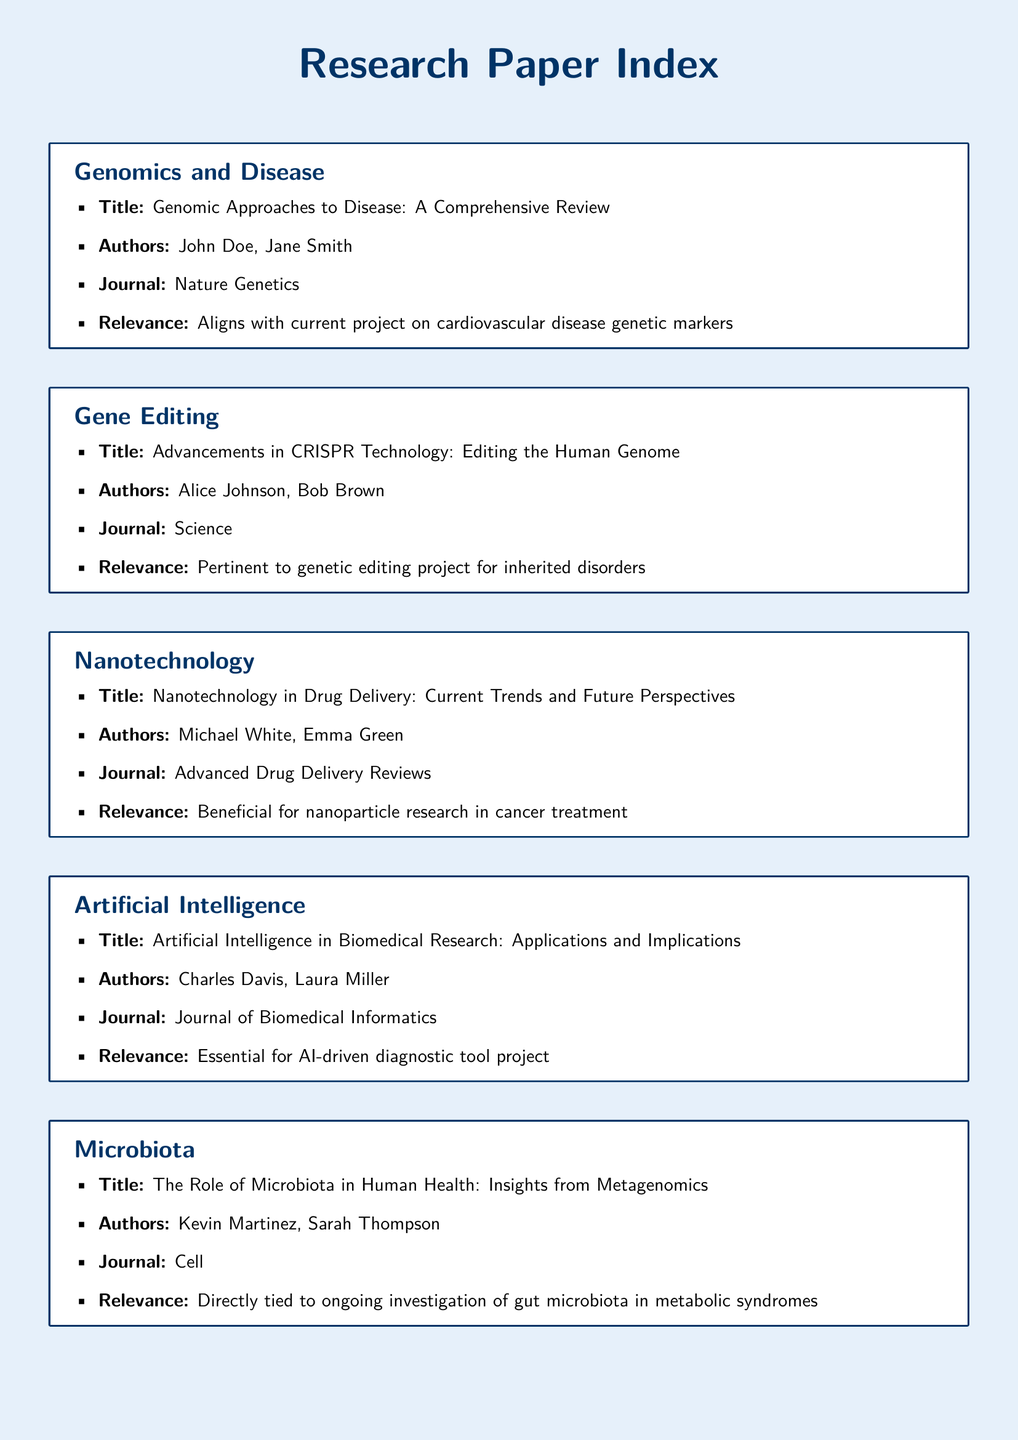what is the title of the genomic paper? The title of the genomic paper is “Genomic Approaches to Disease: A Comprehensive Review.”
Answer: Genomic Approaches to Disease: A Comprehensive Review who authored the paper on CRISPR technology? The CRISPR technology paper was authored by Alice Johnson and Bob Brown.
Answer: Alice Johnson, Bob Brown which journal published the article on drug delivery? The article on drug delivery was published in Advanced Drug Delivery Reviews.
Answer: Advanced Drug Delivery Reviews what is the main relevance of the article about artificial intelligence? The main relevance is that it is essential for the AI-driven diagnostic tool project.
Answer: Essential for AI-driven diagnostic tool project how many authors contributed to the microbiota paper? The microbiota paper was authored by Kevin Martinez and Sarah Thompson, contributing a total of two authors.
Answer: Two authors what scientific domain does the nanotechnology paper belong to? The scientific domain of the nanotechnology paper is Nanotechnology.
Answer: Nanotechnology which paper is associated with ongoing research on metabolic syndromes? The paper associated with ongoing research on metabolic syndromes is “The Role of Microbiota in Human Health: Insights from Metagenomics.”
Answer: The Role of Microbiota in Human Health: Insights from Metagenomics what is the relevance of the genomic approaches paper? The relevance of the genomic approaches paper is that it aligns with the current project on cardiovascular disease genetic markers.
Answer: Aligns with current project on cardiovascular disease genetic markers in which journal can the article about artificial intelligence be found? The article about artificial intelligence can be found in the Journal of Biomedical Informatics.
Answer: Journal of Biomedical Informatics 